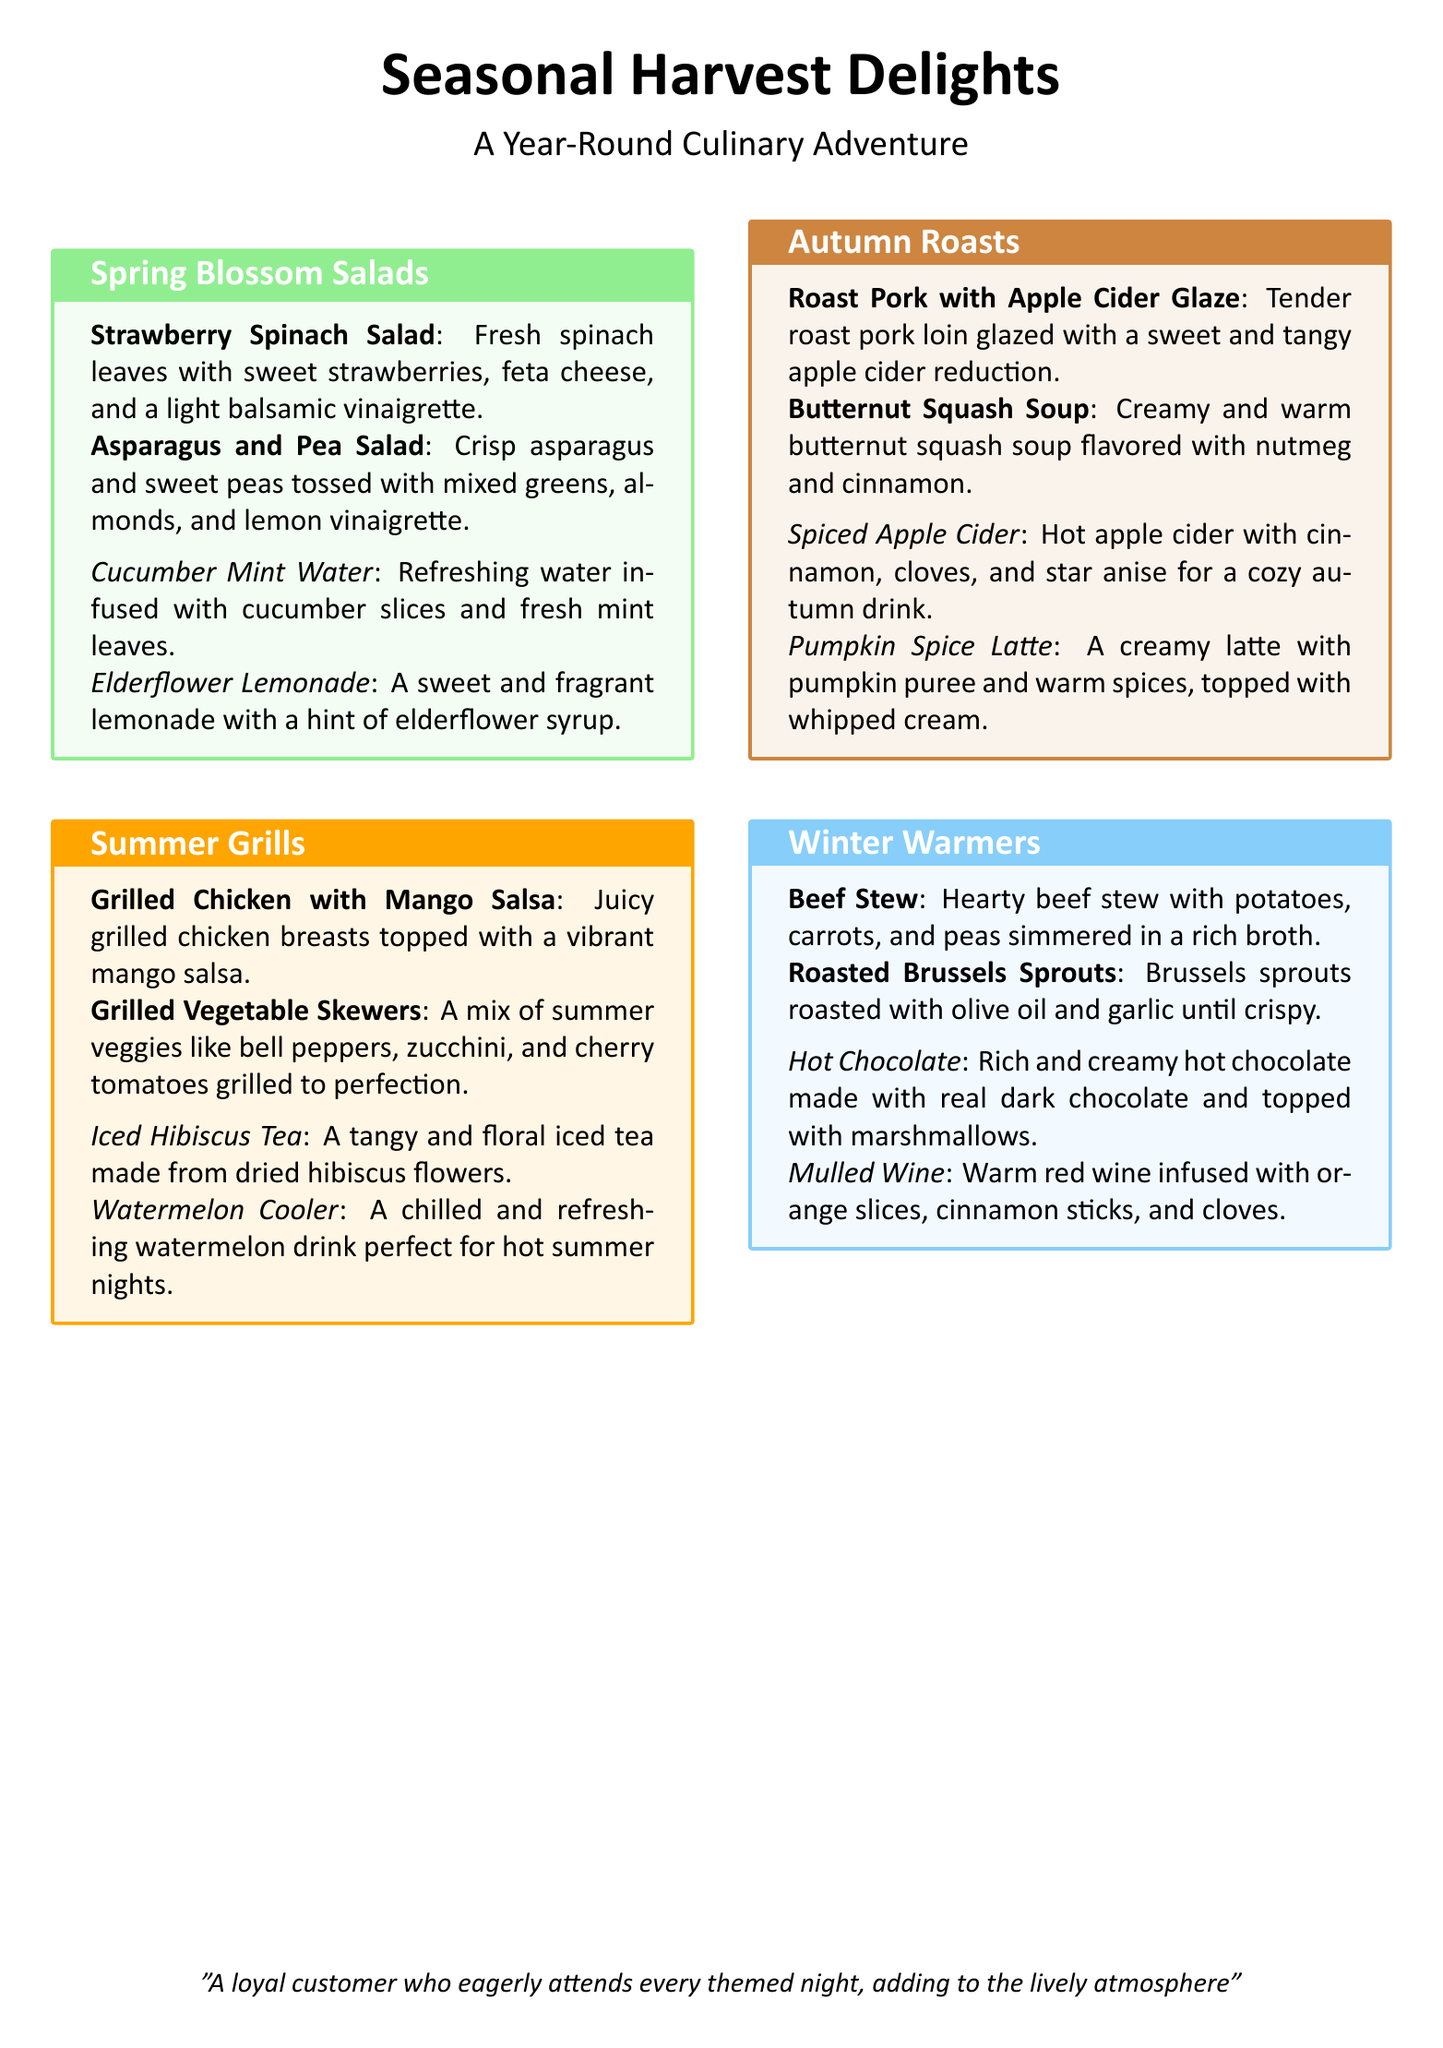What are the two salads offered in the Spring Blossom Salads? The question asks for specific dishes under the Spring Blossom Salads section of the meal plan, which are Strawberry Spinach Salad and Asparagus and Pea Salad.
Answer: Strawberry Spinach Salad, Asparagus and Pea Salad What drink is featured with the Autumn Roasts? The question inquires about the beverage provided alongside the Autumn Roasts section of the meal plan, which includes Spiced Apple Cider and Pumpkin Spice Latte.
Answer: Spiced Apple Cider, Pumpkin Spice Latte How many types of beverages are listed for Summer Grills? This question looks for the count of beverage items under the Summer Grills section, which includes two beverages: Iced Hibiscus Tea and Watermelon Cooler.
Answer: 2 What is the main ingredient in the Beef Stew? The question identifies a key ingredient in the Beef Stew dish under Winter Warmers, which is made with hearty beef.
Answer: Beef Which themed night features a mix of summer veggies on skewers? The question is about the themed night that includes Grilled Vegetable Skewers, which are part of the Summer Grills.
Answer: Summer Grills What type of drink is Mulled Wine? This question is focused on the nature of the drink Mulled Wine, asking for it to be classified, as described in the Winter Warmers section of the meal plan.
Answer: Warm red wine 